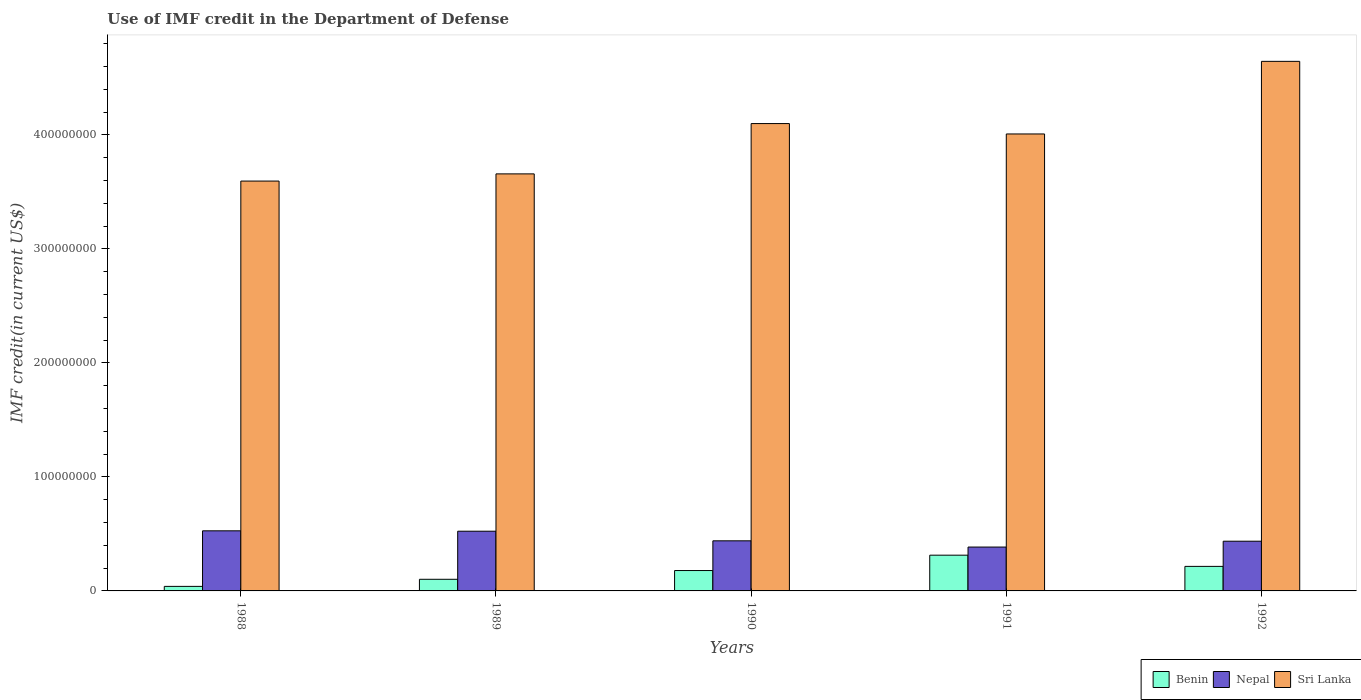How many groups of bars are there?
Offer a terse response. 5. How many bars are there on the 4th tick from the left?
Your answer should be very brief. 3. What is the label of the 1st group of bars from the left?
Make the answer very short. 1988. What is the IMF credit in the Department of Defense in Sri Lanka in 1990?
Your answer should be very brief. 4.10e+08. Across all years, what is the maximum IMF credit in the Department of Defense in Nepal?
Your answer should be compact. 5.27e+07. Across all years, what is the minimum IMF credit in the Department of Defense in Sri Lanka?
Give a very brief answer. 3.59e+08. What is the total IMF credit in the Department of Defense in Nepal in the graph?
Your response must be concise. 2.31e+08. What is the difference between the IMF credit in the Department of Defense in Sri Lanka in 1988 and that in 1989?
Provide a short and direct response. -6.31e+06. What is the difference between the IMF credit in the Department of Defense in Sri Lanka in 1988 and the IMF credit in the Department of Defense in Nepal in 1990?
Provide a short and direct response. 3.15e+08. What is the average IMF credit in the Department of Defense in Nepal per year?
Keep it short and to the point. 4.62e+07. In the year 1991, what is the difference between the IMF credit in the Department of Defense in Sri Lanka and IMF credit in the Department of Defense in Benin?
Provide a succinct answer. 3.69e+08. In how many years, is the IMF credit in the Department of Defense in Nepal greater than 360000000 US$?
Make the answer very short. 0. What is the ratio of the IMF credit in the Department of Defense in Benin in 1988 to that in 1991?
Your answer should be very brief. 0.13. Is the difference between the IMF credit in the Department of Defense in Sri Lanka in 1990 and 1991 greater than the difference between the IMF credit in the Department of Defense in Benin in 1990 and 1991?
Provide a short and direct response. Yes. What is the difference between the highest and the second highest IMF credit in the Department of Defense in Sri Lanka?
Ensure brevity in your answer.  5.46e+07. What is the difference between the highest and the lowest IMF credit in the Department of Defense in Sri Lanka?
Provide a succinct answer. 1.05e+08. In how many years, is the IMF credit in the Department of Defense in Benin greater than the average IMF credit in the Department of Defense in Benin taken over all years?
Offer a very short reply. 3. What does the 3rd bar from the left in 1990 represents?
Offer a very short reply. Sri Lanka. What does the 3rd bar from the right in 1990 represents?
Give a very brief answer. Benin. Is it the case that in every year, the sum of the IMF credit in the Department of Defense in Benin and IMF credit in the Department of Defense in Sri Lanka is greater than the IMF credit in the Department of Defense in Nepal?
Make the answer very short. Yes. How many years are there in the graph?
Give a very brief answer. 5. Are the values on the major ticks of Y-axis written in scientific E-notation?
Keep it short and to the point. No. Does the graph contain any zero values?
Give a very brief answer. No. Where does the legend appear in the graph?
Make the answer very short. Bottom right. What is the title of the graph?
Provide a succinct answer. Use of IMF credit in the Department of Defense. Does "Sub-Saharan Africa (developing only)" appear as one of the legend labels in the graph?
Provide a short and direct response. No. What is the label or title of the X-axis?
Keep it short and to the point. Years. What is the label or title of the Y-axis?
Offer a terse response. IMF credit(in current US$). What is the IMF credit(in current US$) in Benin in 1988?
Your response must be concise. 3.98e+06. What is the IMF credit(in current US$) in Nepal in 1988?
Offer a very short reply. 5.27e+07. What is the IMF credit(in current US$) of Sri Lanka in 1988?
Offer a very short reply. 3.59e+08. What is the IMF credit(in current US$) in Benin in 1989?
Provide a succinct answer. 1.02e+07. What is the IMF credit(in current US$) of Nepal in 1989?
Offer a very short reply. 5.24e+07. What is the IMF credit(in current US$) of Sri Lanka in 1989?
Keep it short and to the point. 3.66e+08. What is the IMF credit(in current US$) in Benin in 1990?
Ensure brevity in your answer.  1.79e+07. What is the IMF credit(in current US$) in Nepal in 1990?
Your answer should be compact. 4.39e+07. What is the IMF credit(in current US$) in Sri Lanka in 1990?
Provide a short and direct response. 4.10e+08. What is the IMF credit(in current US$) of Benin in 1991?
Keep it short and to the point. 3.13e+07. What is the IMF credit(in current US$) in Nepal in 1991?
Give a very brief answer. 3.85e+07. What is the IMF credit(in current US$) of Sri Lanka in 1991?
Your answer should be very brief. 4.01e+08. What is the IMF credit(in current US$) in Benin in 1992?
Offer a very short reply. 2.15e+07. What is the IMF credit(in current US$) in Nepal in 1992?
Your answer should be compact. 4.36e+07. What is the IMF credit(in current US$) in Sri Lanka in 1992?
Make the answer very short. 4.64e+08. Across all years, what is the maximum IMF credit(in current US$) of Benin?
Provide a short and direct response. 3.13e+07. Across all years, what is the maximum IMF credit(in current US$) in Nepal?
Offer a very short reply. 5.27e+07. Across all years, what is the maximum IMF credit(in current US$) of Sri Lanka?
Your response must be concise. 4.64e+08. Across all years, what is the minimum IMF credit(in current US$) of Benin?
Your answer should be compact. 3.98e+06. Across all years, what is the minimum IMF credit(in current US$) of Nepal?
Make the answer very short. 3.85e+07. Across all years, what is the minimum IMF credit(in current US$) in Sri Lanka?
Provide a short and direct response. 3.59e+08. What is the total IMF credit(in current US$) of Benin in the graph?
Provide a succinct answer. 8.49e+07. What is the total IMF credit(in current US$) of Nepal in the graph?
Ensure brevity in your answer.  2.31e+08. What is the total IMF credit(in current US$) of Sri Lanka in the graph?
Keep it short and to the point. 2.00e+09. What is the difference between the IMF credit(in current US$) of Benin in 1988 and that in 1989?
Give a very brief answer. -6.22e+06. What is the difference between the IMF credit(in current US$) in Nepal in 1988 and that in 1989?
Your response must be concise. 3.32e+05. What is the difference between the IMF credit(in current US$) in Sri Lanka in 1988 and that in 1989?
Provide a short and direct response. -6.31e+06. What is the difference between the IMF credit(in current US$) in Benin in 1988 and that in 1990?
Your response must be concise. -1.39e+07. What is the difference between the IMF credit(in current US$) of Nepal in 1988 and that in 1990?
Your answer should be very brief. 8.76e+06. What is the difference between the IMF credit(in current US$) in Sri Lanka in 1988 and that in 1990?
Offer a terse response. -5.04e+07. What is the difference between the IMF credit(in current US$) in Benin in 1988 and that in 1991?
Provide a short and direct response. -2.74e+07. What is the difference between the IMF credit(in current US$) of Nepal in 1988 and that in 1991?
Provide a succinct answer. 1.42e+07. What is the difference between the IMF credit(in current US$) of Sri Lanka in 1988 and that in 1991?
Keep it short and to the point. -4.13e+07. What is the difference between the IMF credit(in current US$) in Benin in 1988 and that in 1992?
Offer a very short reply. -1.75e+07. What is the difference between the IMF credit(in current US$) in Nepal in 1988 and that in 1992?
Keep it short and to the point. 9.11e+06. What is the difference between the IMF credit(in current US$) of Sri Lanka in 1988 and that in 1992?
Your answer should be very brief. -1.05e+08. What is the difference between the IMF credit(in current US$) in Benin in 1989 and that in 1990?
Ensure brevity in your answer.  -7.68e+06. What is the difference between the IMF credit(in current US$) in Nepal in 1989 and that in 1990?
Keep it short and to the point. 8.43e+06. What is the difference between the IMF credit(in current US$) of Sri Lanka in 1989 and that in 1990?
Provide a succinct answer. -4.41e+07. What is the difference between the IMF credit(in current US$) of Benin in 1989 and that in 1991?
Your answer should be compact. -2.11e+07. What is the difference between the IMF credit(in current US$) of Nepal in 1989 and that in 1991?
Ensure brevity in your answer.  1.39e+07. What is the difference between the IMF credit(in current US$) in Sri Lanka in 1989 and that in 1991?
Make the answer very short. -3.50e+07. What is the difference between the IMF credit(in current US$) of Benin in 1989 and that in 1992?
Keep it short and to the point. -1.13e+07. What is the difference between the IMF credit(in current US$) in Nepal in 1989 and that in 1992?
Your answer should be very brief. 8.78e+06. What is the difference between the IMF credit(in current US$) of Sri Lanka in 1989 and that in 1992?
Offer a terse response. -9.87e+07. What is the difference between the IMF credit(in current US$) of Benin in 1990 and that in 1991?
Your answer should be very brief. -1.35e+07. What is the difference between the IMF credit(in current US$) in Nepal in 1990 and that in 1991?
Ensure brevity in your answer.  5.47e+06. What is the difference between the IMF credit(in current US$) of Sri Lanka in 1990 and that in 1991?
Provide a succinct answer. 9.10e+06. What is the difference between the IMF credit(in current US$) of Benin in 1990 and that in 1992?
Ensure brevity in your answer.  -3.64e+06. What is the difference between the IMF credit(in current US$) in Nepal in 1990 and that in 1992?
Give a very brief answer. 3.48e+05. What is the difference between the IMF credit(in current US$) of Sri Lanka in 1990 and that in 1992?
Provide a short and direct response. -5.46e+07. What is the difference between the IMF credit(in current US$) in Benin in 1991 and that in 1992?
Provide a succinct answer. 9.82e+06. What is the difference between the IMF credit(in current US$) in Nepal in 1991 and that in 1992?
Ensure brevity in your answer.  -5.12e+06. What is the difference between the IMF credit(in current US$) of Sri Lanka in 1991 and that in 1992?
Ensure brevity in your answer.  -6.37e+07. What is the difference between the IMF credit(in current US$) in Benin in 1988 and the IMF credit(in current US$) in Nepal in 1989?
Make the answer very short. -4.84e+07. What is the difference between the IMF credit(in current US$) in Benin in 1988 and the IMF credit(in current US$) in Sri Lanka in 1989?
Provide a short and direct response. -3.62e+08. What is the difference between the IMF credit(in current US$) of Nepal in 1988 and the IMF credit(in current US$) of Sri Lanka in 1989?
Keep it short and to the point. -3.13e+08. What is the difference between the IMF credit(in current US$) in Benin in 1988 and the IMF credit(in current US$) in Nepal in 1990?
Offer a terse response. -4.00e+07. What is the difference between the IMF credit(in current US$) of Benin in 1988 and the IMF credit(in current US$) of Sri Lanka in 1990?
Offer a very short reply. -4.06e+08. What is the difference between the IMF credit(in current US$) in Nepal in 1988 and the IMF credit(in current US$) in Sri Lanka in 1990?
Give a very brief answer. -3.57e+08. What is the difference between the IMF credit(in current US$) in Benin in 1988 and the IMF credit(in current US$) in Nepal in 1991?
Your answer should be very brief. -3.45e+07. What is the difference between the IMF credit(in current US$) in Benin in 1988 and the IMF credit(in current US$) in Sri Lanka in 1991?
Your response must be concise. -3.97e+08. What is the difference between the IMF credit(in current US$) in Nepal in 1988 and the IMF credit(in current US$) in Sri Lanka in 1991?
Give a very brief answer. -3.48e+08. What is the difference between the IMF credit(in current US$) in Benin in 1988 and the IMF credit(in current US$) in Nepal in 1992?
Your answer should be compact. -3.96e+07. What is the difference between the IMF credit(in current US$) in Benin in 1988 and the IMF credit(in current US$) in Sri Lanka in 1992?
Offer a very short reply. -4.60e+08. What is the difference between the IMF credit(in current US$) of Nepal in 1988 and the IMF credit(in current US$) of Sri Lanka in 1992?
Your answer should be compact. -4.12e+08. What is the difference between the IMF credit(in current US$) in Benin in 1989 and the IMF credit(in current US$) in Nepal in 1990?
Provide a short and direct response. -3.37e+07. What is the difference between the IMF credit(in current US$) of Benin in 1989 and the IMF credit(in current US$) of Sri Lanka in 1990?
Offer a terse response. -4.00e+08. What is the difference between the IMF credit(in current US$) in Nepal in 1989 and the IMF credit(in current US$) in Sri Lanka in 1990?
Provide a succinct answer. -3.57e+08. What is the difference between the IMF credit(in current US$) of Benin in 1989 and the IMF credit(in current US$) of Nepal in 1991?
Your answer should be very brief. -2.83e+07. What is the difference between the IMF credit(in current US$) in Benin in 1989 and the IMF credit(in current US$) in Sri Lanka in 1991?
Provide a succinct answer. -3.91e+08. What is the difference between the IMF credit(in current US$) of Nepal in 1989 and the IMF credit(in current US$) of Sri Lanka in 1991?
Your response must be concise. -3.48e+08. What is the difference between the IMF credit(in current US$) in Benin in 1989 and the IMF credit(in current US$) in Nepal in 1992?
Your answer should be very brief. -3.34e+07. What is the difference between the IMF credit(in current US$) of Benin in 1989 and the IMF credit(in current US$) of Sri Lanka in 1992?
Your answer should be very brief. -4.54e+08. What is the difference between the IMF credit(in current US$) of Nepal in 1989 and the IMF credit(in current US$) of Sri Lanka in 1992?
Provide a short and direct response. -4.12e+08. What is the difference between the IMF credit(in current US$) in Benin in 1990 and the IMF credit(in current US$) in Nepal in 1991?
Your answer should be very brief. -2.06e+07. What is the difference between the IMF credit(in current US$) of Benin in 1990 and the IMF credit(in current US$) of Sri Lanka in 1991?
Offer a very short reply. -3.83e+08. What is the difference between the IMF credit(in current US$) in Nepal in 1990 and the IMF credit(in current US$) in Sri Lanka in 1991?
Give a very brief answer. -3.57e+08. What is the difference between the IMF credit(in current US$) in Benin in 1990 and the IMF credit(in current US$) in Nepal in 1992?
Offer a very short reply. -2.57e+07. What is the difference between the IMF credit(in current US$) of Benin in 1990 and the IMF credit(in current US$) of Sri Lanka in 1992?
Offer a very short reply. -4.47e+08. What is the difference between the IMF credit(in current US$) in Nepal in 1990 and the IMF credit(in current US$) in Sri Lanka in 1992?
Provide a short and direct response. -4.20e+08. What is the difference between the IMF credit(in current US$) of Benin in 1991 and the IMF credit(in current US$) of Nepal in 1992?
Provide a succinct answer. -1.23e+07. What is the difference between the IMF credit(in current US$) of Benin in 1991 and the IMF credit(in current US$) of Sri Lanka in 1992?
Your response must be concise. -4.33e+08. What is the difference between the IMF credit(in current US$) of Nepal in 1991 and the IMF credit(in current US$) of Sri Lanka in 1992?
Offer a terse response. -4.26e+08. What is the average IMF credit(in current US$) in Benin per year?
Your answer should be very brief. 1.70e+07. What is the average IMF credit(in current US$) in Nepal per year?
Offer a very short reply. 4.62e+07. What is the average IMF credit(in current US$) in Sri Lanka per year?
Give a very brief answer. 4.00e+08. In the year 1988, what is the difference between the IMF credit(in current US$) of Benin and IMF credit(in current US$) of Nepal?
Make the answer very short. -4.87e+07. In the year 1988, what is the difference between the IMF credit(in current US$) in Benin and IMF credit(in current US$) in Sri Lanka?
Keep it short and to the point. -3.55e+08. In the year 1988, what is the difference between the IMF credit(in current US$) of Nepal and IMF credit(in current US$) of Sri Lanka?
Your answer should be compact. -3.07e+08. In the year 1989, what is the difference between the IMF credit(in current US$) of Benin and IMF credit(in current US$) of Nepal?
Provide a succinct answer. -4.22e+07. In the year 1989, what is the difference between the IMF credit(in current US$) in Benin and IMF credit(in current US$) in Sri Lanka?
Your answer should be very brief. -3.56e+08. In the year 1989, what is the difference between the IMF credit(in current US$) in Nepal and IMF credit(in current US$) in Sri Lanka?
Give a very brief answer. -3.13e+08. In the year 1990, what is the difference between the IMF credit(in current US$) in Benin and IMF credit(in current US$) in Nepal?
Your answer should be compact. -2.61e+07. In the year 1990, what is the difference between the IMF credit(in current US$) in Benin and IMF credit(in current US$) in Sri Lanka?
Make the answer very short. -3.92e+08. In the year 1990, what is the difference between the IMF credit(in current US$) in Nepal and IMF credit(in current US$) in Sri Lanka?
Provide a short and direct response. -3.66e+08. In the year 1991, what is the difference between the IMF credit(in current US$) of Benin and IMF credit(in current US$) of Nepal?
Your answer should be very brief. -7.14e+06. In the year 1991, what is the difference between the IMF credit(in current US$) of Benin and IMF credit(in current US$) of Sri Lanka?
Your answer should be compact. -3.69e+08. In the year 1991, what is the difference between the IMF credit(in current US$) of Nepal and IMF credit(in current US$) of Sri Lanka?
Keep it short and to the point. -3.62e+08. In the year 1992, what is the difference between the IMF credit(in current US$) of Benin and IMF credit(in current US$) of Nepal?
Provide a succinct answer. -2.21e+07. In the year 1992, what is the difference between the IMF credit(in current US$) in Benin and IMF credit(in current US$) in Sri Lanka?
Your answer should be very brief. -4.43e+08. In the year 1992, what is the difference between the IMF credit(in current US$) in Nepal and IMF credit(in current US$) in Sri Lanka?
Offer a very short reply. -4.21e+08. What is the ratio of the IMF credit(in current US$) of Benin in 1988 to that in 1989?
Your answer should be very brief. 0.39. What is the ratio of the IMF credit(in current US$) in Sri Lanka in 1988 to that in 1989?
Your response must be concise. 0.98. What is the ratio of the IMF credit(in current US$) of Benin in 1988 to that in 1990?
Your answer should be compact. 0.22. What is the ratio of the IMF credit(in current US$) in Nepal in 1988 to that in 1990?
Your answer should be compact. 1.2. What is the ratio of the IMF credit(in current US$) of Sri Lanka in 1988 to that in 1990?
Ensure brevity in your answer.  0.88. What is the ratio of the IMF credit(in current US$) in Benin in 1988 to that in 1991?
Keep it short and to the point. 0.13. What is the ratio of the IMF credit(in current US$) of Nepal in 1988 to that in 1991?
Your response must be concise. 1.37. What is the ratio of the IMF credit(in current US$) in Sri Lanka in 1988 to that in 1991?
Your response must be concise. 0.9. What is the ratio of the IMF credit(in current US$) of Benin in 1988 to that in 1992?
Provide a succinct answer. 0.18. What is the ratio of the IMF credit(in current US$) in Nepal in 1988 to that in 1992?
Offer a terse response. 1.21. What is the ratio of the IMF credit(in current US$) in Sri Lanka in 1988 to that in 1992?
Provide a succinct answer. 0.77. What is the ratio of the IMF credit(in current US$) of Benin in 1989 to that in 1990?
Give a very brief answer. 0.57. What is the ratio of the IMF credit(in current US$) in Nepal in 1989 to that in 1990?
Provide a short and direct response. 1.19. What is the ratio of the IMF credit(in current US$) of Sri Lanka in 1989 to that in 1990?
Provide a succinct answer. 0.89. What is the ratio of the IMF credit(in current US$) of Benin in 1989 to that in 1991?
Provide a succinct answer. 0.33. What is the ratio of the IMF credit(in current US$) of Nepal in 1989 to that in 1991?
Provide a succinct answer. 1.36. What is the ratio of the IMF credit(in current US$) of Sri Lanka in 1989 to that in 1991?
Ensure brevity in your answer.  0.91. What is the ratio of the IMF credit(in current US$) of Benin in 1989 to that in 1992?
Give a very brief answer. 0.47. What is the ratio of the IMF credit(in current US$) of Nepal in 1989 to that in 1992?
Provide a short and direct response. 1.2. What is the ratio of the IMF credit(in current US$) in Sri Lanka in 1989 to that in 1992?
Offer a terse response. 0.79. What is the ratio of the IMF credit(in current US$) of Benin in 1990 to that in 1991?
Your answer should be very brief. 0.57. What is the ratio of the IMF credit(in current US$) of Nepal in 1990 to that in 1991?
Your answer should be very brief. 1.14. What is the ratio of the IMF credit(in current US$) in Sri Lanka in 1990 to that in 1991?
Provide a succinct answer. 1.02. What is the ratio of the IMF credit(in current US$) in Benin in 1990 to that in 1992?
Make the answer very short. 0.83. What is the ratio of the IMF credit(in current US$) in Sri Lanka in 1990 to that in 1992?
Make the answer very short. 0.88. What is the ratio of the IMF credit(in current US$) of Benin in 1991 to that in 1992?
Your answer should be compact. 1.46. What is the ratio of the IMF credit(in current US$) of Nepal in 1991 to that in 1992?
Ensure brevity in your answer.  0.88. What is the ratio of the IMF credit(in current US$) in Sri Lanka in 1991 to that in 1992?
Keep it short and to the point. 0.86. What is the difference between the highest and the second highest IMF credit(in current US$) in Benin?
Make the answer very short. 9.82e+06. What is the difference between the highest and the second highest IMF credit(in current US$) in Nepal?
Ensure brevity in your answer.  3.32e+05. What is the difference between the highest and the second highest IMF credit(in current US$) in Sri Lanka?
Offer a very short reply. 5.46e+07. What is the difference between the highest and the lowest IMF credit(in current US$) of Benin?
Make the answer very short. 2.74e+07. What is the difference between the highest and the lowest IMF credit(in current US$) of Nepal?
Your answer should be compact. 1.42e+07. What is the difference between the highest and the lowest IMF credit(in current US$) of Sri Lanka?
Ensure brevity in your answer.  1.05e+08. 